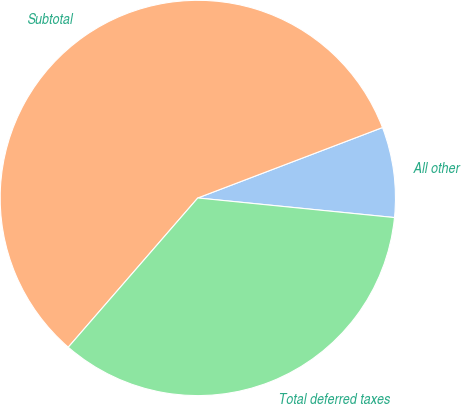Convert chart to OTSL. <chart><loc_0><loc_0><loc_500><loc_500><pie_chart><fcel>All other<fcel>Subtotal<fcel>Total deferred taxes<nl><fcel>7.38%<fcel>57.83%<fcel>34.8%<nl></chart> 